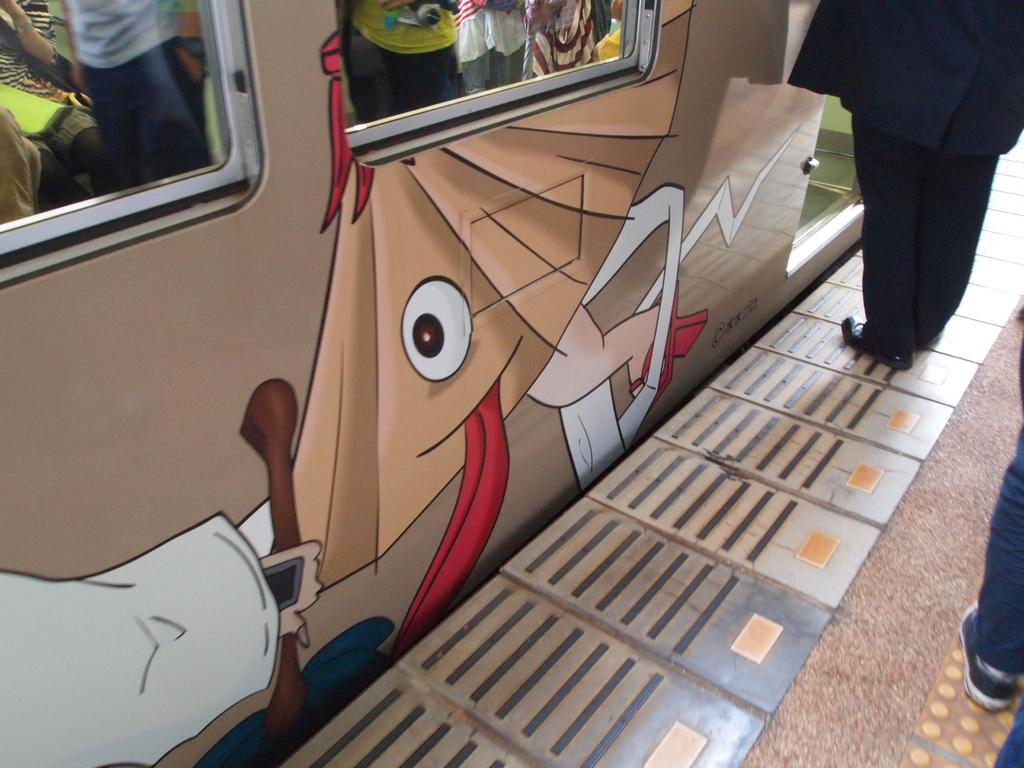What is the main subject in the image? There is a vehicle in the image. Can you describe the person in the image? There is a person standing in the image, and they are wearing a black dress. What can be seen in the background of the image? There are two windows visible in the background of the image. Where is the drawer located in the image? There is no drawer present in the image. What type of nest can be seen in the image? There is no nest present in the image. 